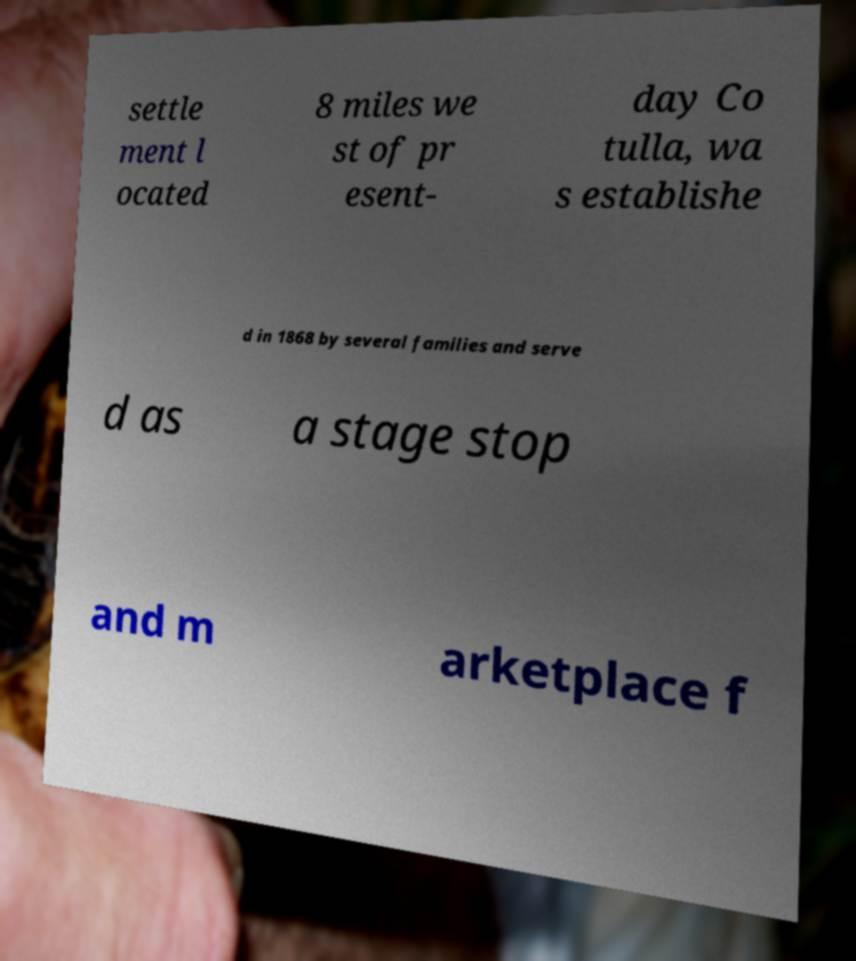Could you assist in decoding the text presented in this image and type it out clearly? settle ment l ocated 8 miles we st of pr esent- day Co tulla, wa s establishe d in 1868 by several families and serve d as a stage stop and m arketplace f 